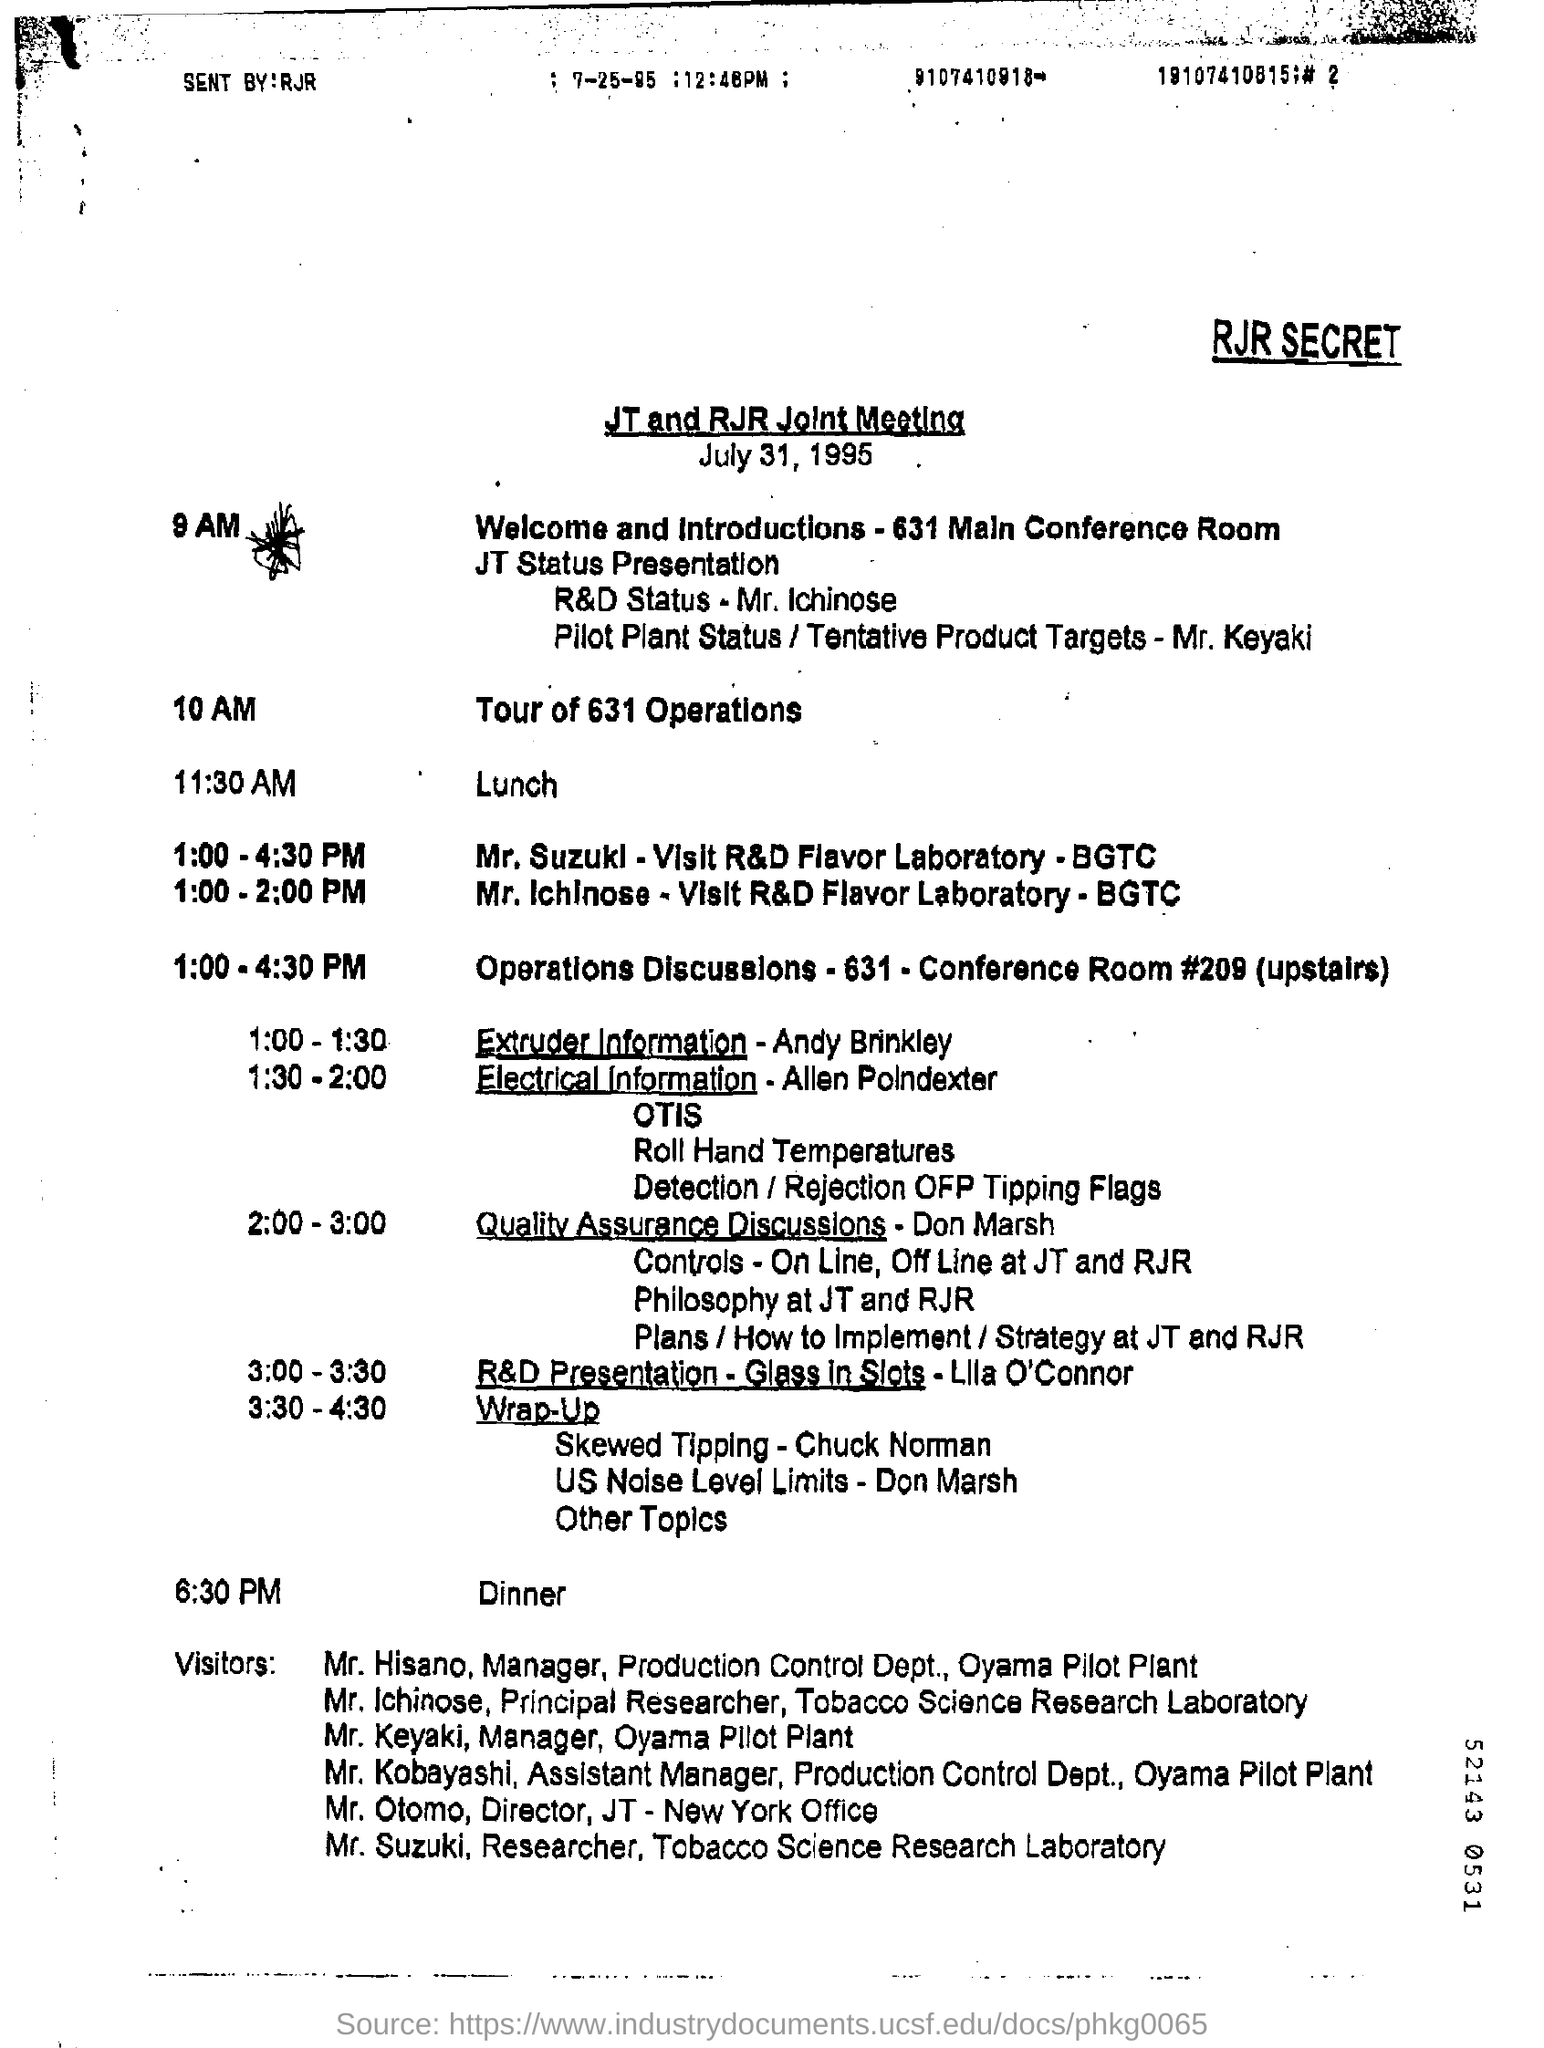What is the Title for the Document?
Your answer should be very brief. JT and RJR joint meeting. What is the Date?
Make the answer very short. July 31, 1995. When is the Lunch?
Ensure brevity in your answer.  11:30 AM. 